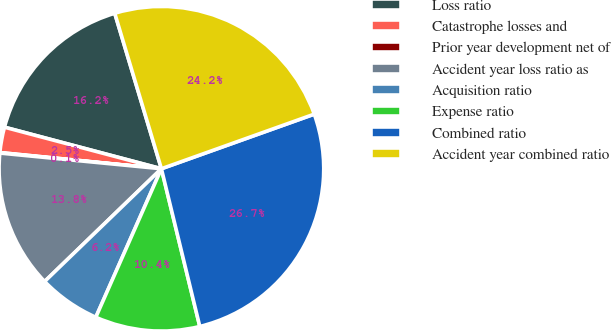<chart> <loc_0><loc_0><loc_500><loc_500><pie_chart><fcel>Loss ratio<fcel>Catastrophe losses and<fcel>Prior year development net of<fcel>Accident year loss ratio as<fcel>Acquisition ratio<fcel>Expense ratio<fcel>Combined ratio<fcel>Accident year combined ratio<nl><fcel>16.24%<fcel>2.53%<fcel>0.05%<fcel>13.76%<fcel>6.16%<fcel>10.42%<fcel>26.66%<fcel>24.18%<nl></chart> 